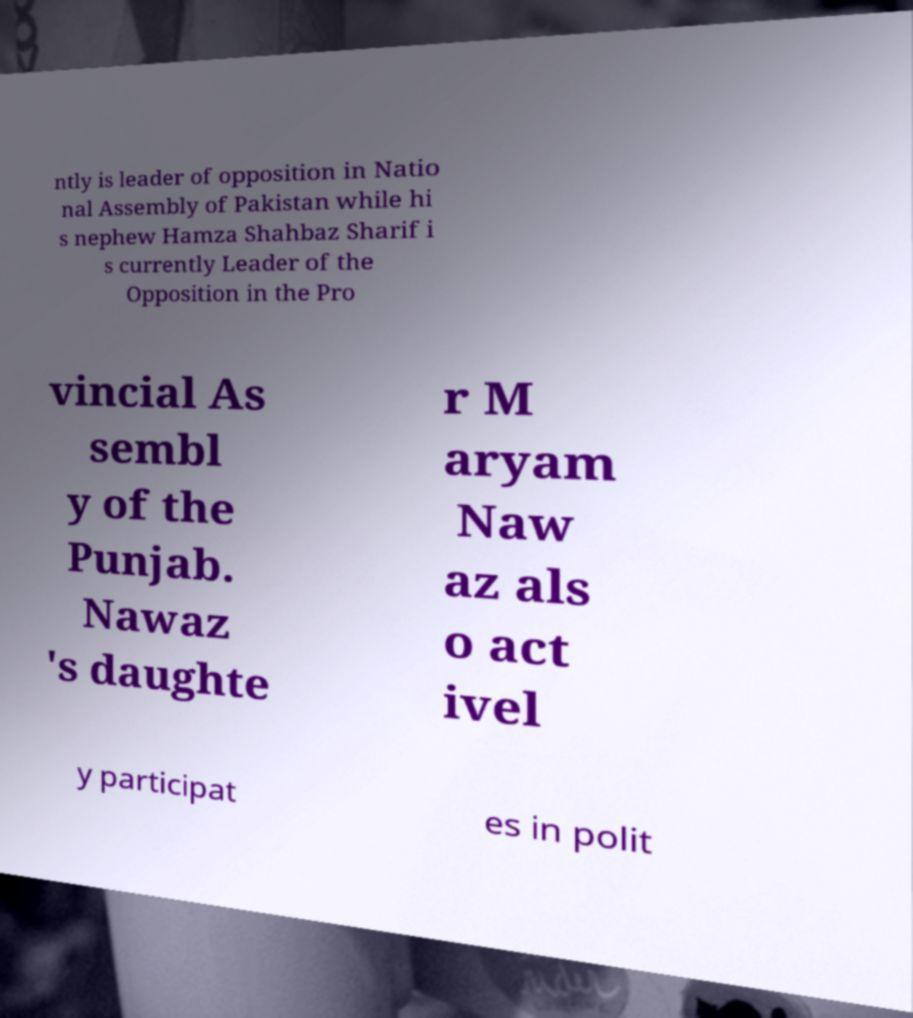Could you assist in decoding the text presented in this image and type it out clearly? ntly is leader of opposition in Natio nal Assembly of Pakistan while hi s nephew Hamza Shahbaz Sharif i s currently Leader of the Opposition in the Pro vincial As sembl y of the Punjab. Nawaz 's daughte r M aryam Naw az als o act ivel y participat es in polit 